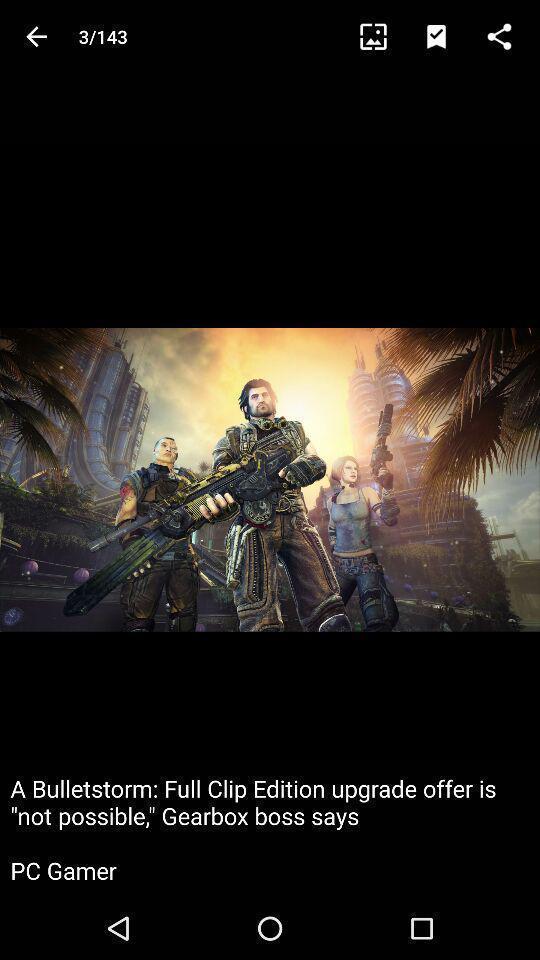Provide a textual representation of this image. Screen showing an image of gaming application. 